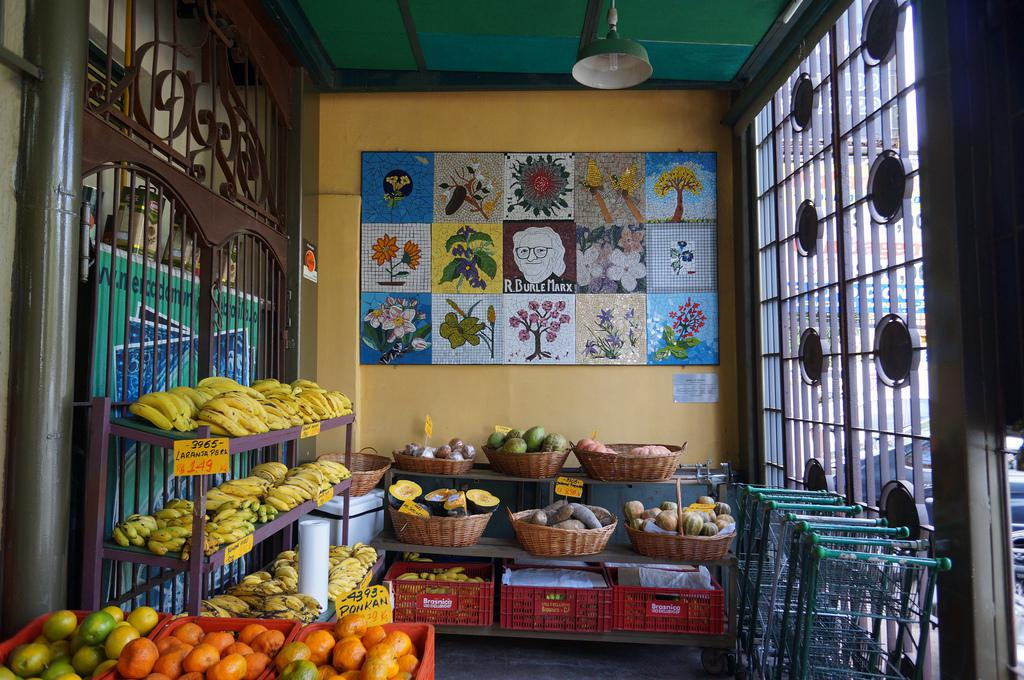Question: where is the light?
Choices:
A. Above the table.
B. Hanging over the counter.
C. On the ceiling.
D. Hanging over the mirror.
Answer with the letter. Answer: C Question: why are there images on the wall?
Choices:
A. For decoration purposes.
B. To show the artist's work.
C. To advertise.
D. To make the office look friendly.
Answer with the letter. Answer: A Question: what are lined up next to the window?
Choices:
A. Shopping carts.
B. Cars.
C. Wild turkeys.
D. Visitors.
Answer with the letter. Answer: A Question: what creates an illusion of space?
Choices:
A. Windows.
B. Open sky.
C. Tall ceilings.
D. Mirrors.
Answer with the letter. Answer: A Question: what color are the handles in the shopping carts?
Choices:
A. Blue.
B. Green.
C. Red.
D. Grey.
Answer with the letter. Answer: B Question: where is the daylight coming from?
Choices:
A. Through the window.
B. Through the blinds.
C. Through the bottom window.
D. Through the top window.
Answer with the letter. Answer: A Question: how many paintings are on the wall?
Choices:
A. One.
B. Two.
C. Fifteen.
D. Three.
Answer with the letter. Answer: C Question: what is on the shelves?
Choices:
A. Bananas.
B. Apples.
C. Corn.
D. Peas.
Answer with the letter. Answer: A Question: what color is the wall at the back of the image?
Choices:
A. White.
B. Green.
C. Blue.
D. Yellow.
Answer with the letter. Answer: D Question: what is in the basket?
Choices:
A. Lemons and oranges.
B. Puppies.
C. Fabric.
D. Laundry.
Answer with the letter. Answer: A Question: what is off?
Choices:
A. The TV.
B. Ceiling light.
C. The coffee pot.
D. The radio.
Answer with the letter. Answer: B Question: how are the bananas placed?
Choices:
A. In bunches.
B. In rows.
C. On the table.
D. Next to the peaches.
Answer with the letter. Answer: B Question: what color is the wall in the back?
Choices:
A. Red.
B. Green.
C. Yellow.
D. Purple.
Answer with the letter. Answer: C Question: how is the fruit displayed?
Choices:
A. In baskets.
B. On platters.
C. Hanging above.
D. In a bowl.
Answer with the letter. Answer: A Question: what is beneath the shelves holding baskets?
Choices:
A. Books.
B. Several boxes.
C. Pens and pencils.
D. There are red plastic crates beneath the shelves holding baskets.
Answer with the letter. Answer: D Question: how many shelves are holding bananas?
Choices:
A. Zero.
B. One.
C. Two.
D. At least three shelves holding bananas.
Answer with the letter. Answer: D Question: how many green handled shopping carts?
Choices:
A. Seven.
B. One.
C. Five.
D. Six.
Answer with the letter. Answer: A 